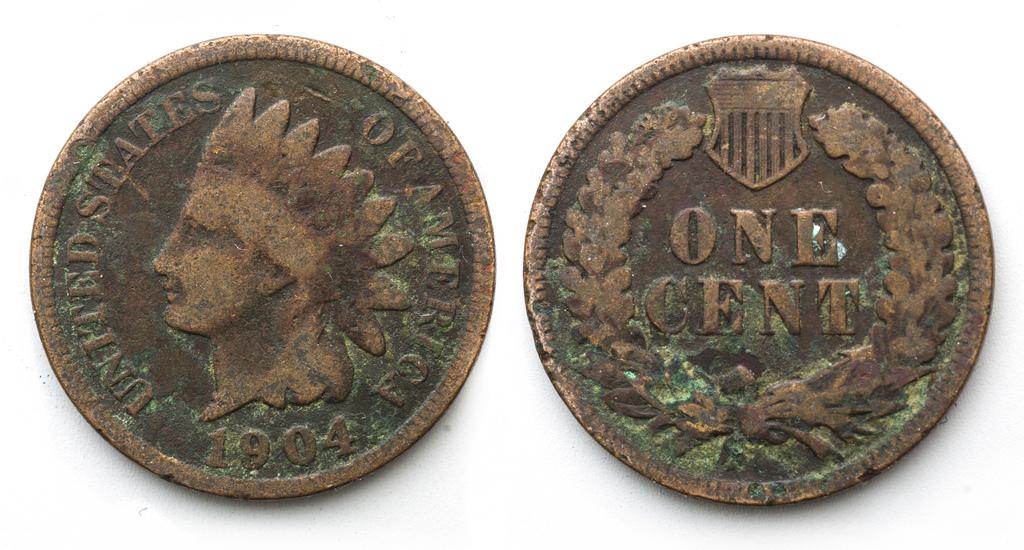How many cent's is this worth?
Ensure brevity in your answer.  One. 